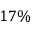<formula> <loc_0><loc_0><loc_500><loc_500>1 7 \%</formula> 